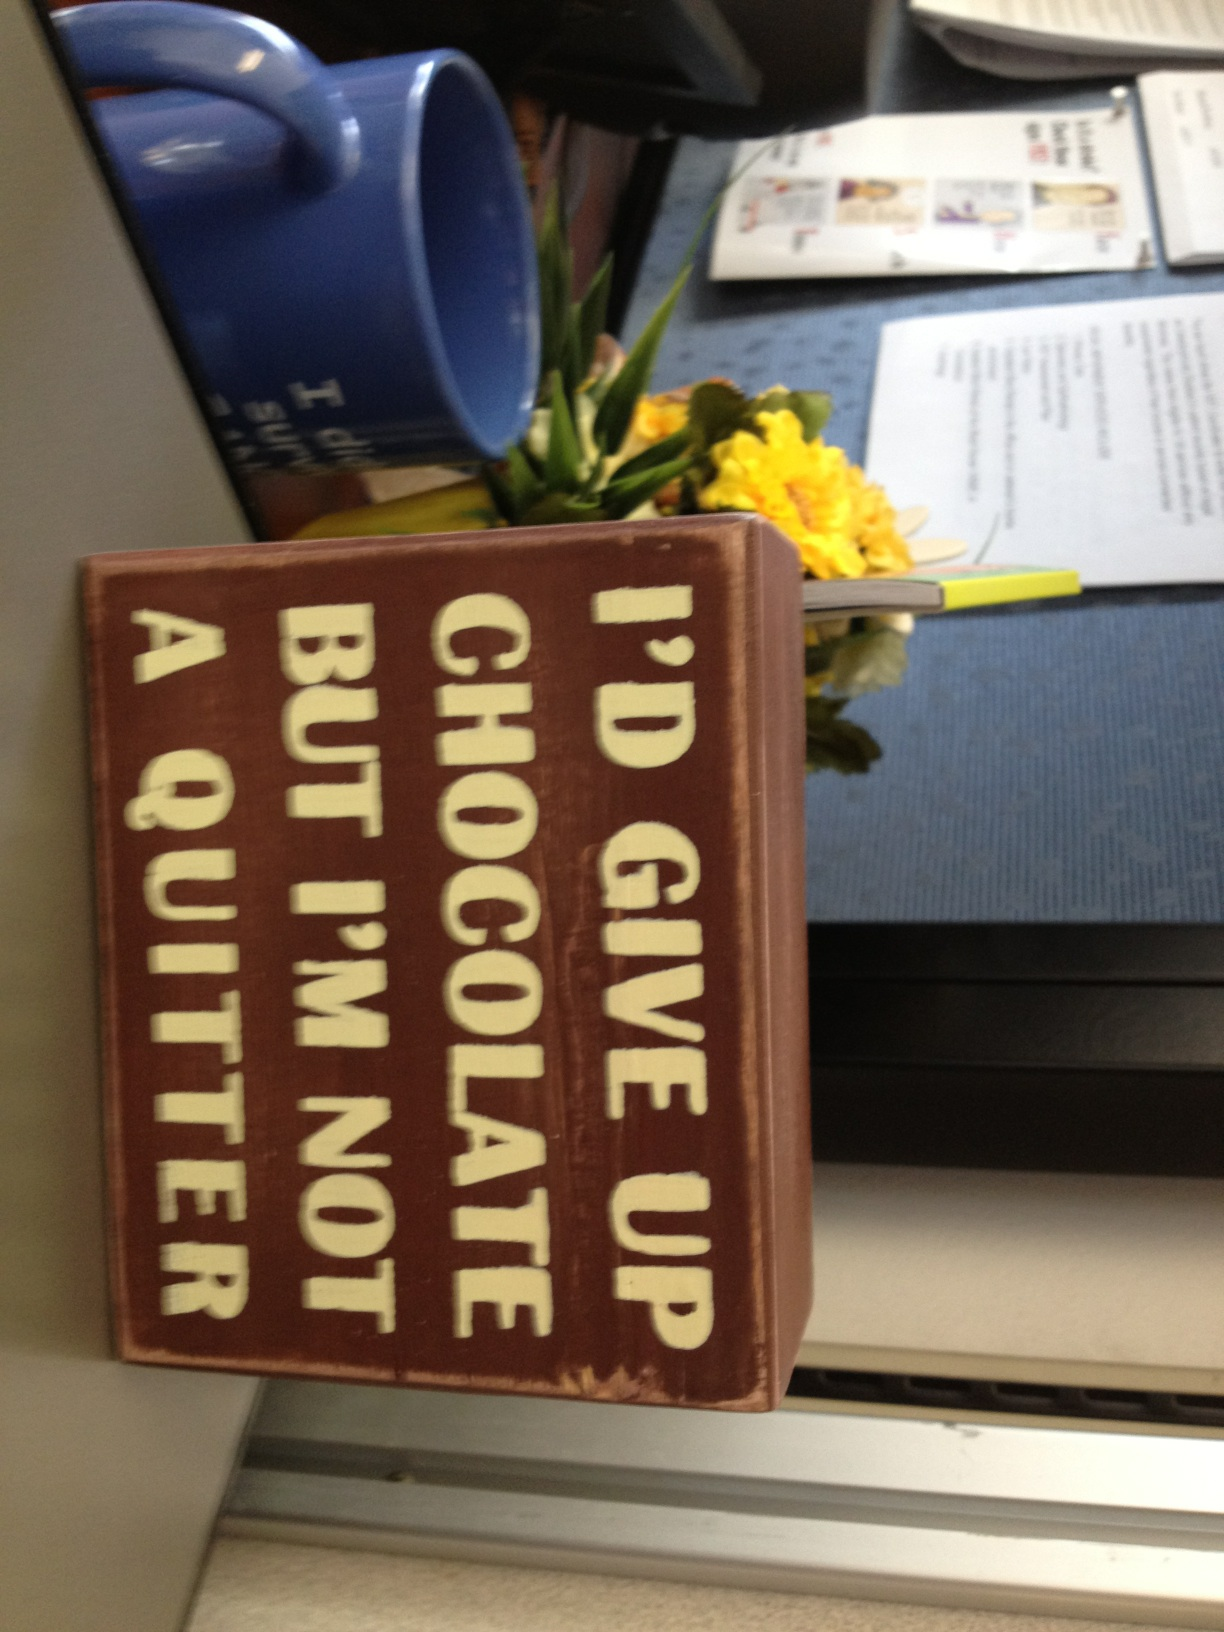Can you describe the background of this image? In the background of the image, there is a blue coffee mug, some flowers with yellow blossoms, a laptop that is partially visible, and some documents or papers laid out on a desk. The background appears to be an office or a workspace. What is the significance of the sign's message in a workplace environment? The sign's message, 'I’d give up chocolate but I’m not a quitter,' adds an element of humor and light-heartedness to the workplace. It reflects a playful attitude towards indulgences and emphasizes perseverance and determination in a humorous way. Such signs often aim to boost morale and create a positive, laid-back atmosphere in a work setting. 